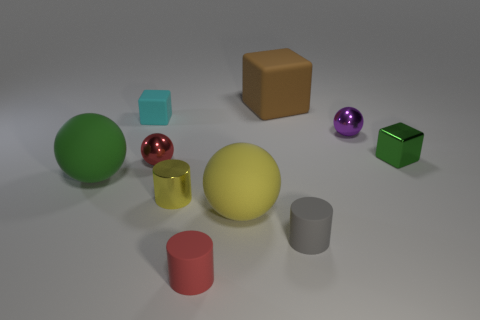Subtract all cylinders. How many objects are left? 7 Subtract 0 blue cubes. How many objects are left? 10 Subtract all tiny cylinders. Subtract all tiny red metallic blocks. How many objects are left? 7 Add 7 small purple balls. How many small purple balls are left? 8 Add 3 large objects. How many large objects exist? 6 